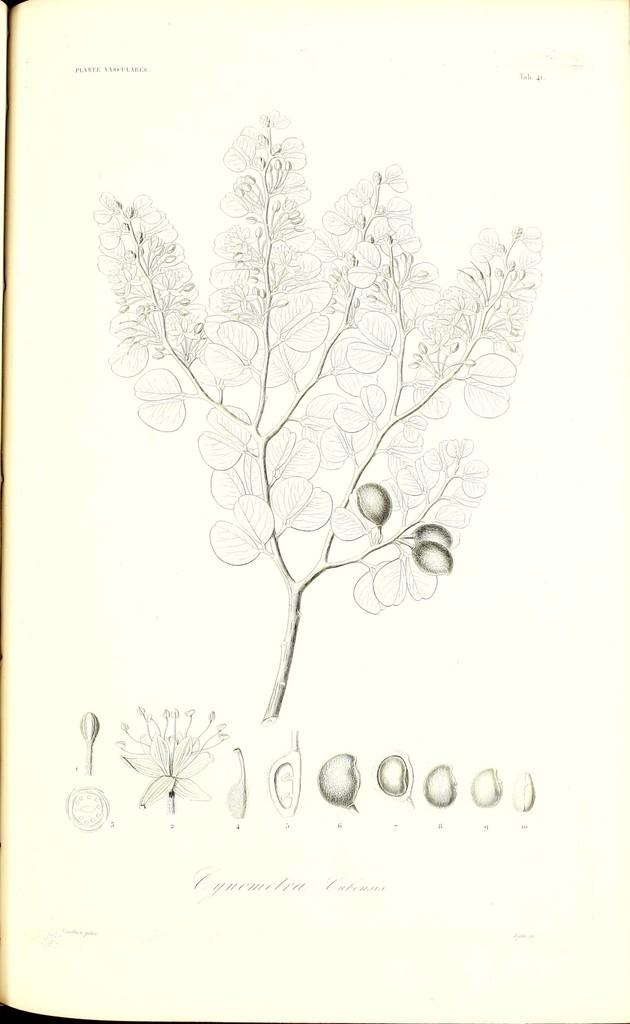What is the main subject of the page? The main subject of the page is a tree. What other elements are present on the page? There are different types of seeds depicted on the page. What type of pain is being experienced by the tree in the image? There is no indication of pain being experienced by the tree in the image. 